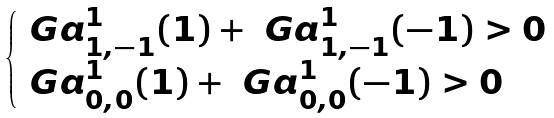Convert formula to latex. <formula><loc_0><loc_0><loc_500><loc_500>\begin{cases} \ G a _ { 1 , - 1 } ^ { 1 } ( 1 ) + \ G a _ { 1 , - 1 } ^ { 1 } ( - 1 ) > 0 \\ \ G a _ { 0 , 0 } ^ { 1 } ( 1 ) + \ G a _ { 0 , 0 } ^ { 1 } ( - 1 ) > 0 \end{cases}</formula> 